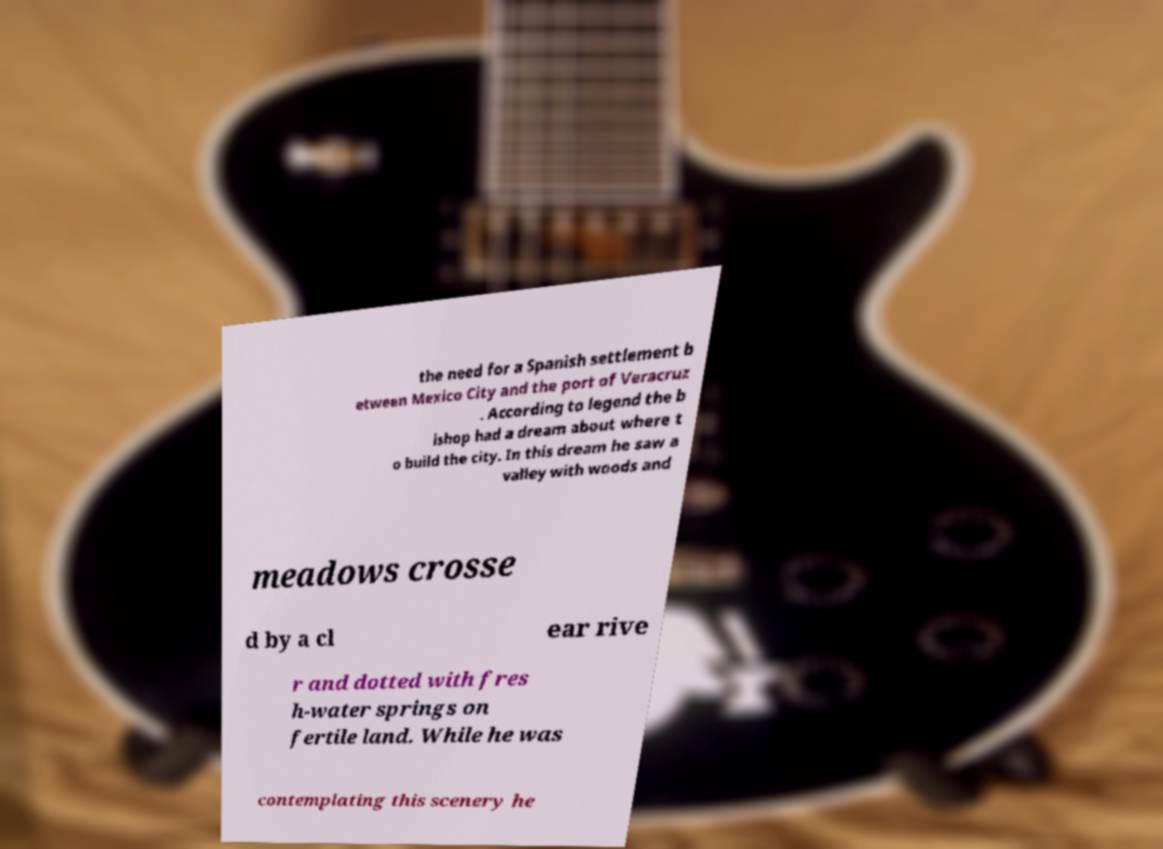There's text embedded in this image that I need extracted. Can you transcribe it verbatim? the need for a Spanish settlement b etween Mexico City and the port of Veracruz . According to legend the b ishop had a dream about where t o build the city. In this dream he saw a valley with woods and meadows crosse d by a cl ear rive r and dotted with fres h-water springs on fertile land. While he was contemplating this scenery he 